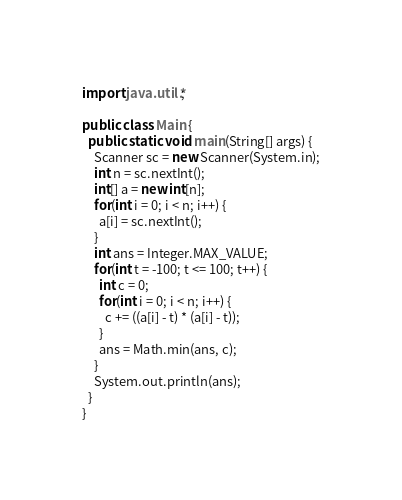Convert code to text. <code><loc_0><loc_0><loc_500><loc_500><_Java_>
import java.util.*;

public class Main {
  public static void main(String[] args) {
    Scanner sc = new Scanner(System.in);
    int n = sc.nextInt();
    int[] a = new int[n];
    for(int i = 0; i < n; i++) {
      a[i] = sc.nextInt();
    }
    int ans = Integer.MAX_VALUE;
    for(int t = -100; t <= 100; t++) {
      int c = 0;
      for(int i = 0; i < n; i++) {
        c += ((a[i] - t) * (a[i] - t));
      }
      ans = Math.min(ans, c);
    }
    System.out.println(ans);
  }
}</code> 